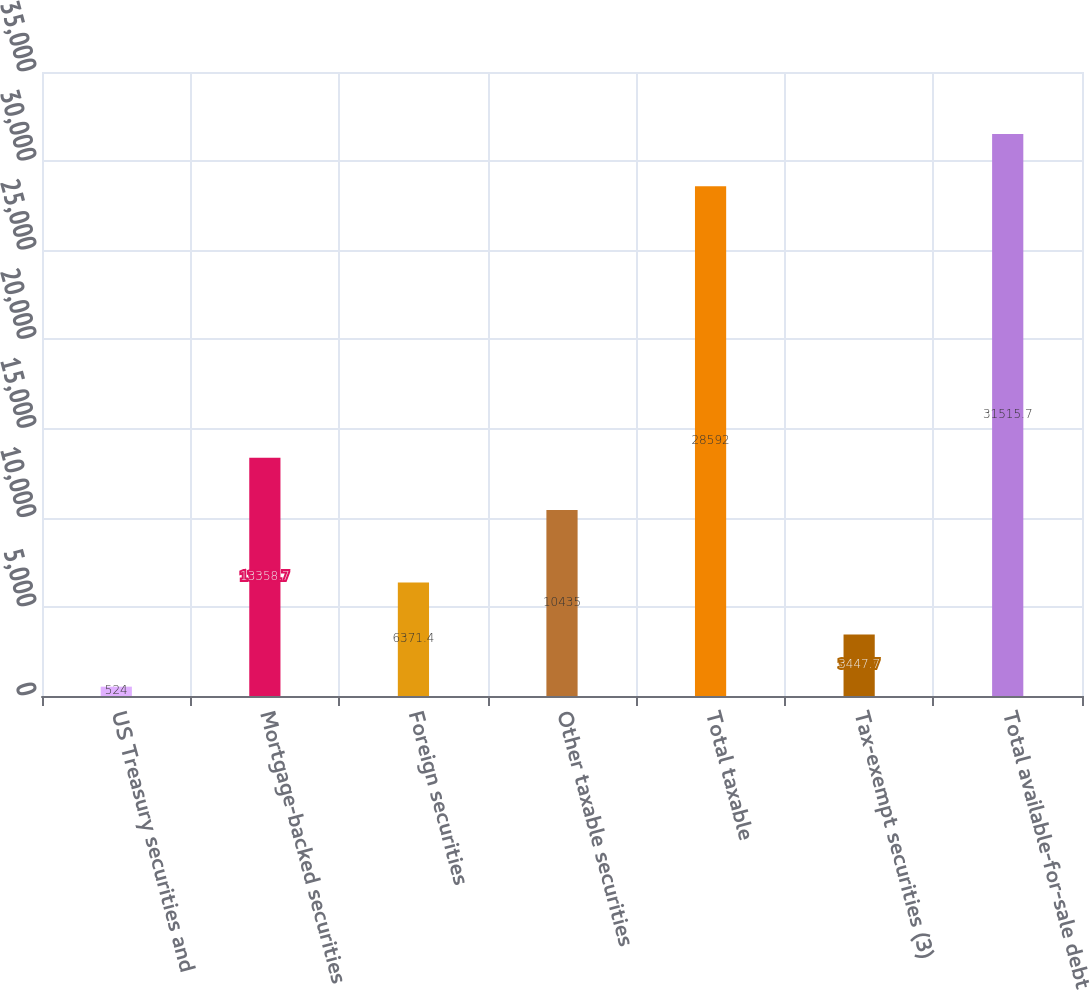<chart> <loc_0><loc_0><loc_500><loc_500><bar_chart><fcel>US Treasury securities and<fcel>Mortgage-backed securities<fcel>Foreign securities<fcel>Other taxable securities<fcel>Total taxable<fcel>Tax-exempt securities (3)<fcel>Total available-for-sale debt<nl><fcel>524<fcel>13358.7<fcel>6371.4<fcel>10435<fcel>28592<fcel>3447.7<fcel>31515.7<nl></chart> 